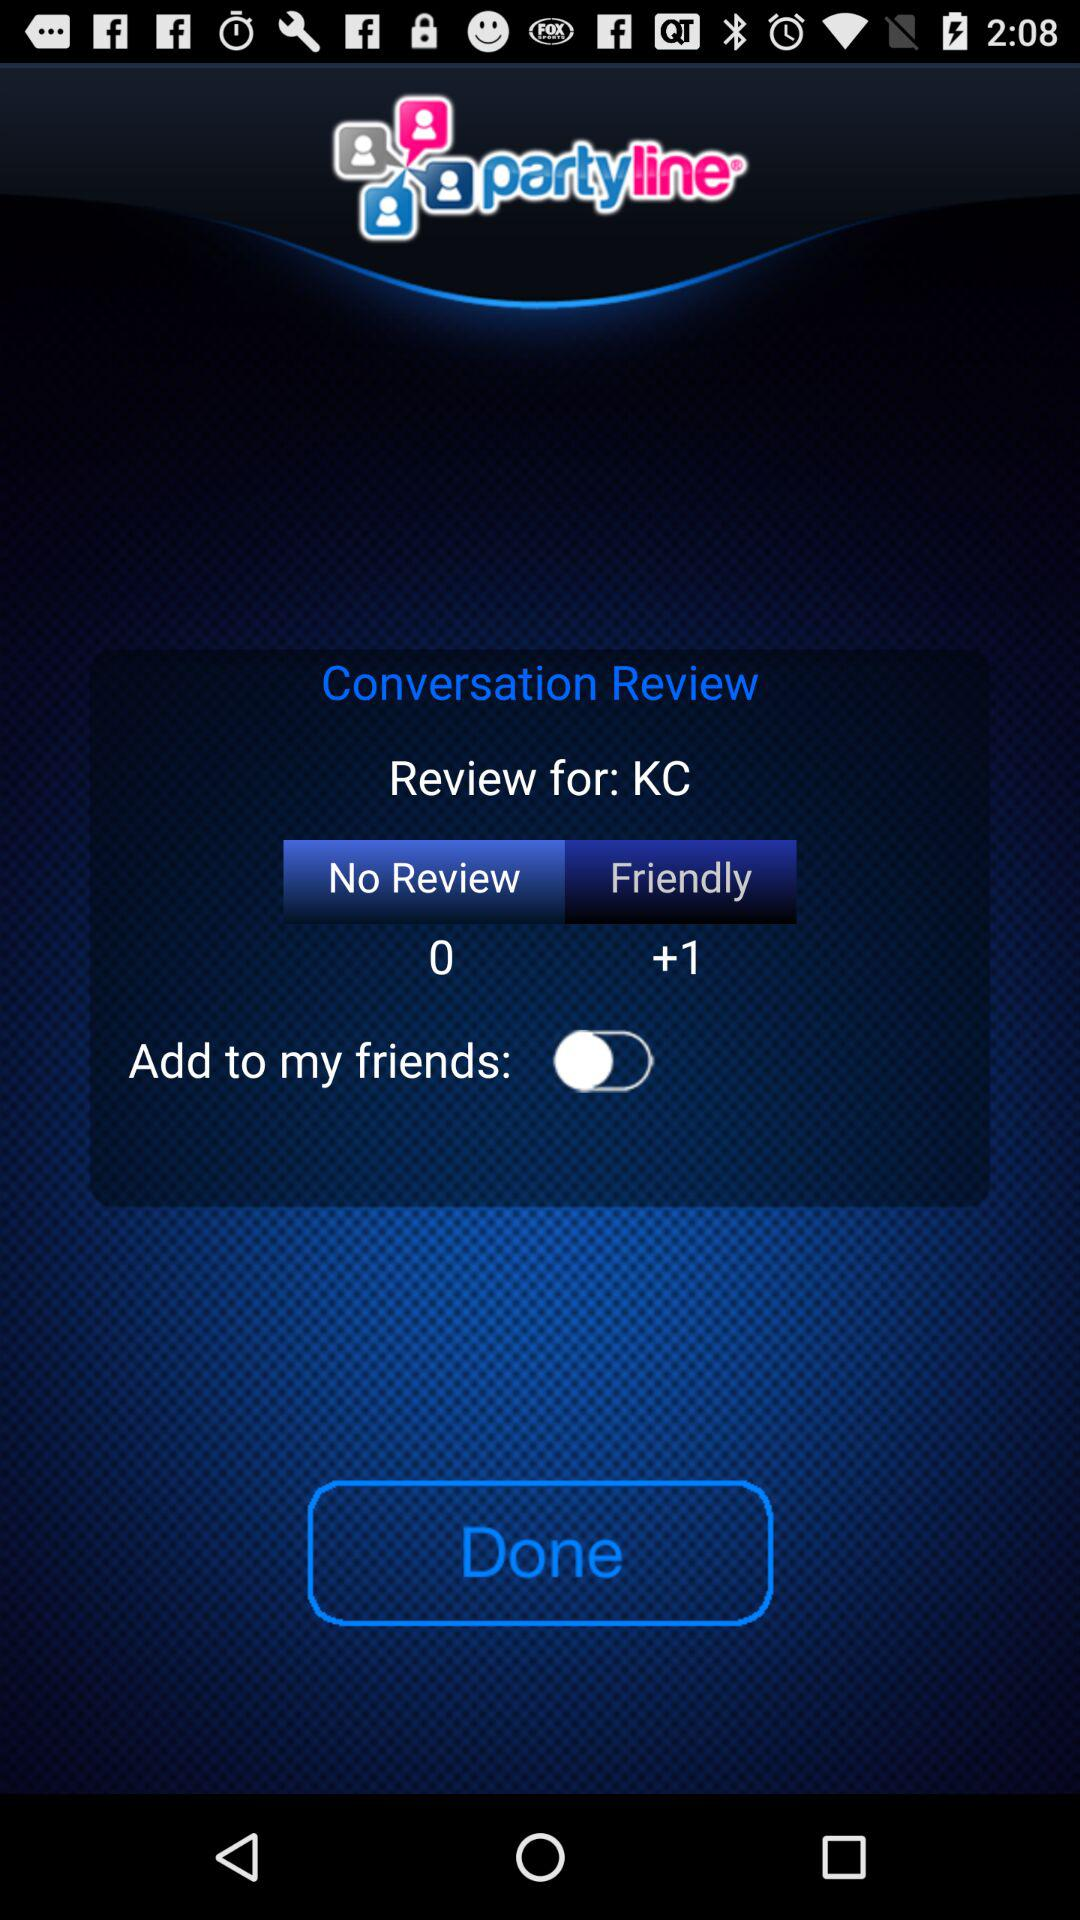What's the status of "Add to my friends"? The status is off. 